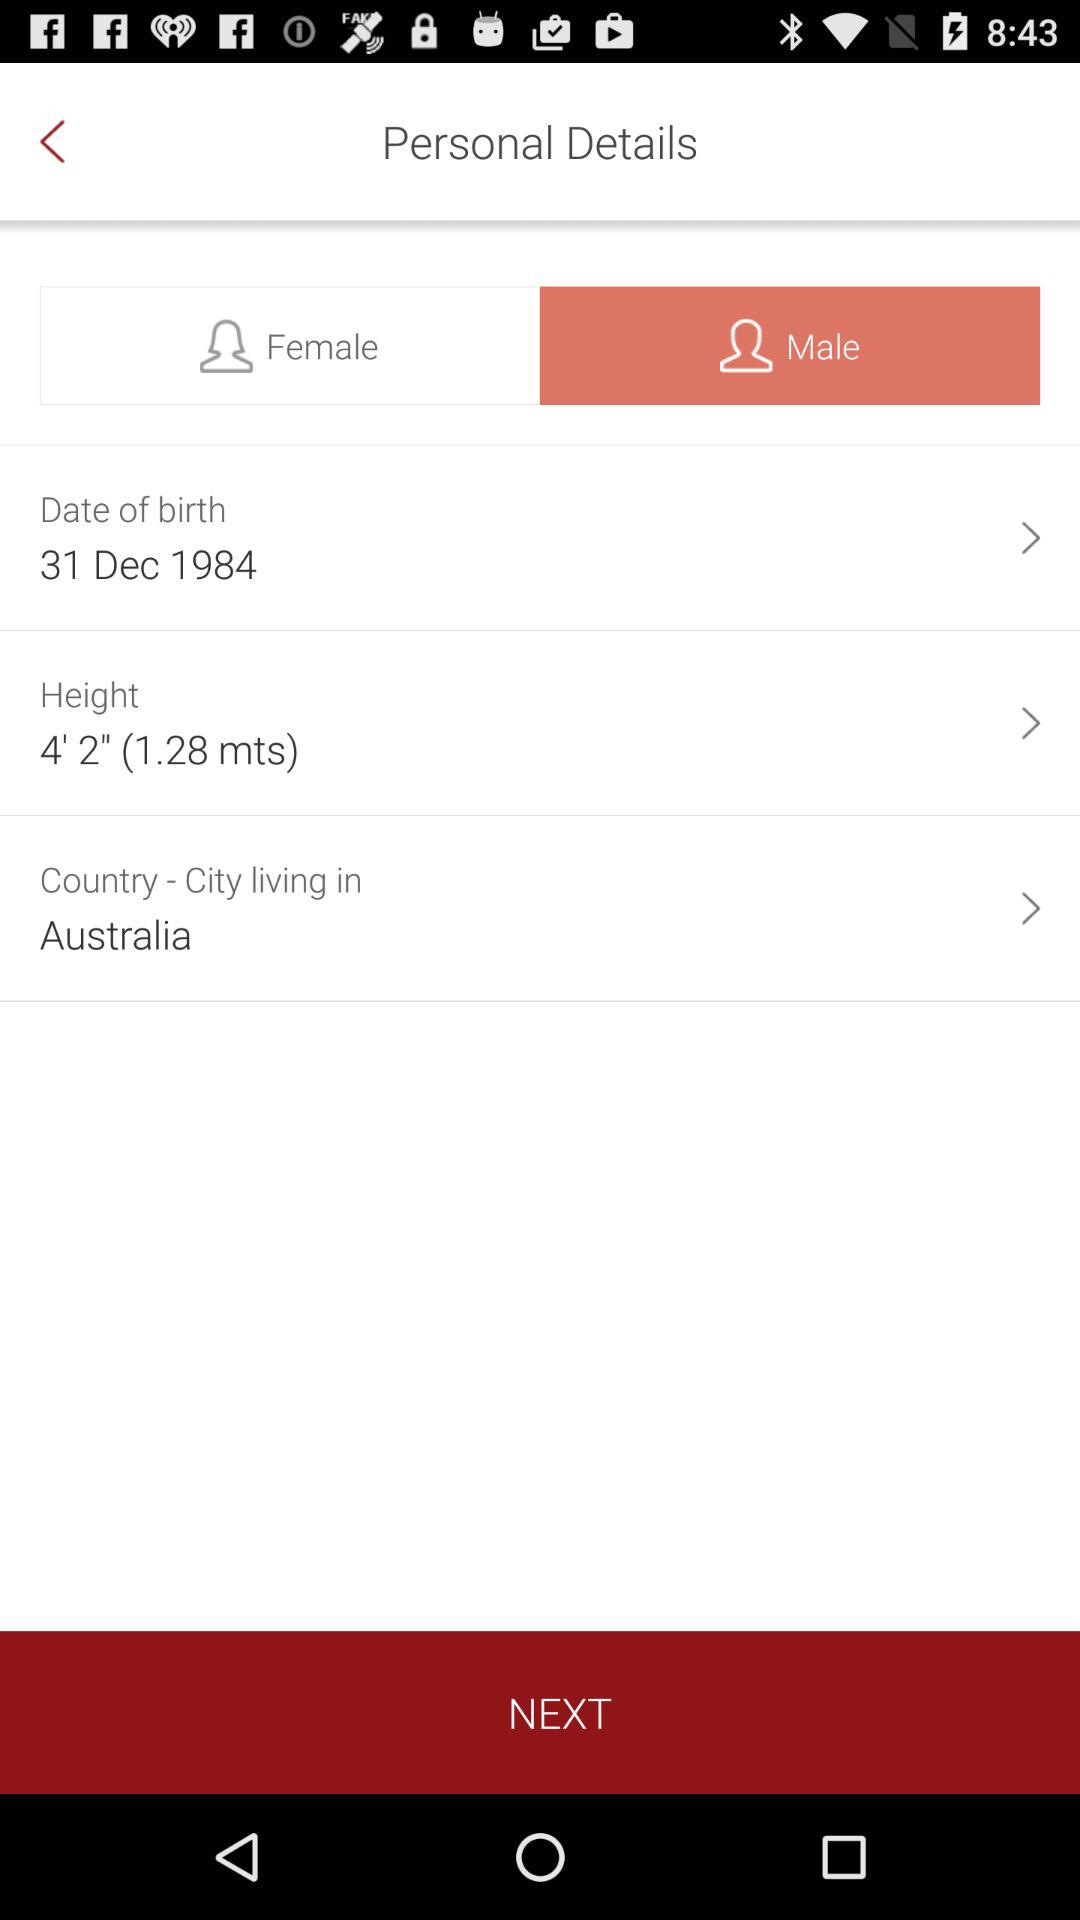What is the height? The height is 4' 2" (1.28 mts). 